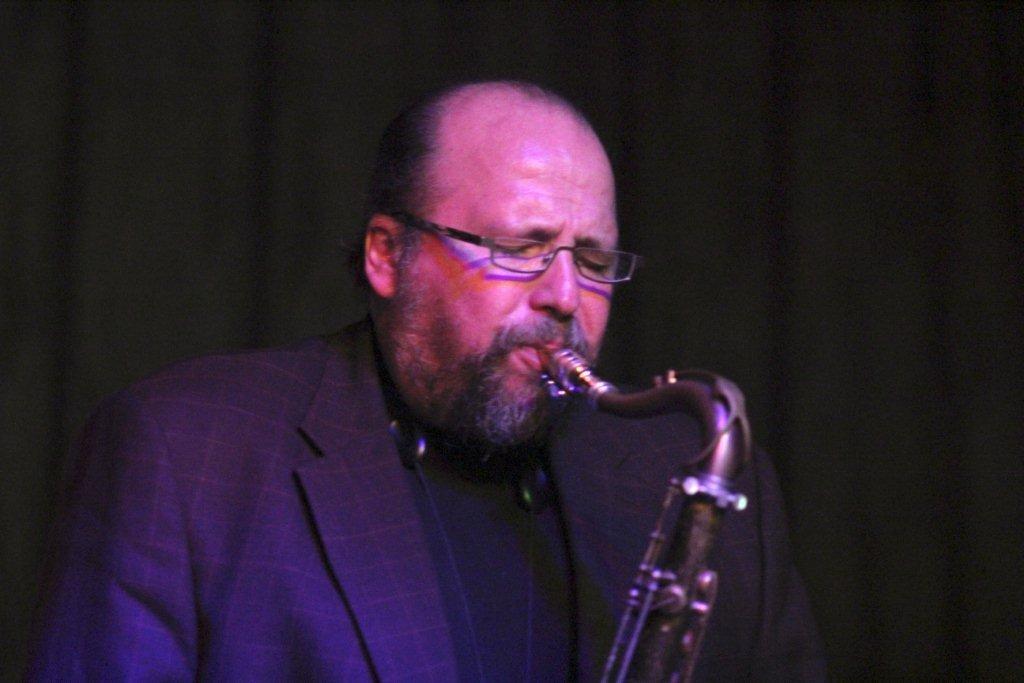Please provide a concise description of this image. In the middle of the image there is a man and he is playing music with a musical instrument. In this image the background is dark. 